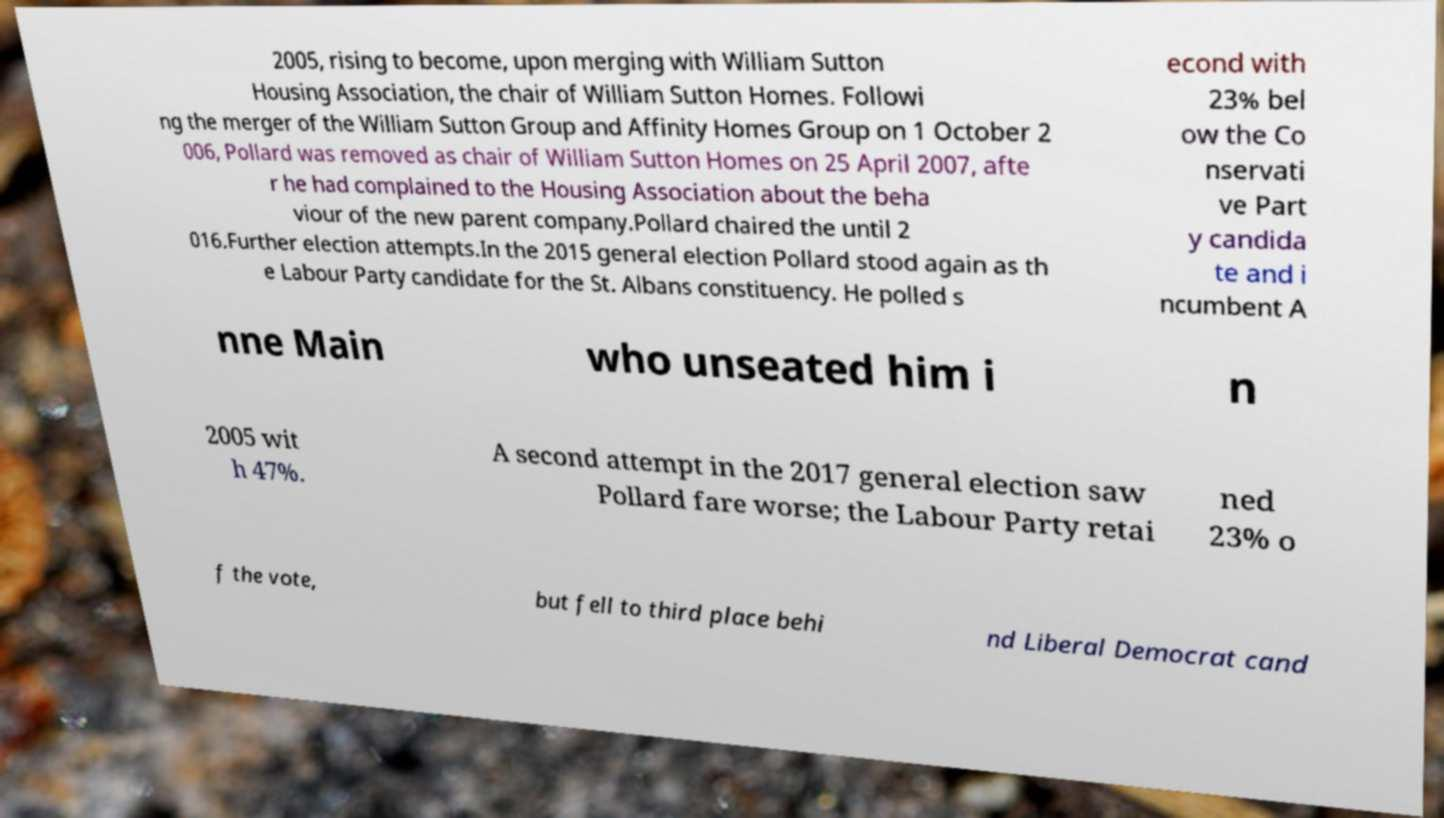For documentation purposes, I need the text within this image transcribed. Could you provide that? 2005, rising to become, upon merging with William Sutton Housing Association, the chair of William Sutton Homes. Followi ng the merger of the William Sutton Group and Affinity Homes Group on 1 October 2 006, Pollard was removed as chair of William Sutton Homes on 25 April 2007, afte r he had complained to the Housing Association about the beha viour of the new parent company.Pollard chaired the until 2 016.Further election attempts.In the 2015 general election Pollard stood again as th e Labour Party candidate for the St. Albans constituency. He polled s econd with 23% bel ow the Co nservati ve Part y candida te and i ncumbent A nne Main who unseated him i n 2005 wit h 47%. A second attempt in the 2017 general election saw Pollard fare worse; the Labour Party retai ned 23% o f the vote, but fell to third place behi nd Liberal Democrat cand 